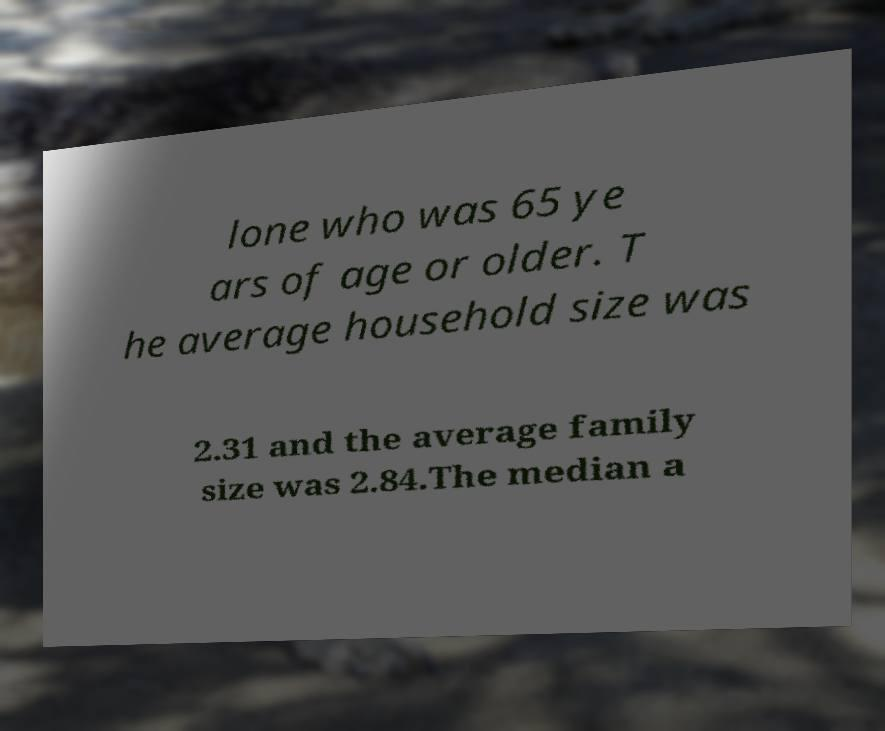Please identify and transcribe the text found in this image. lone who was 65 ye ars of age or older. T he average household size was 2.31 and the average family size was 2.84.The median a 